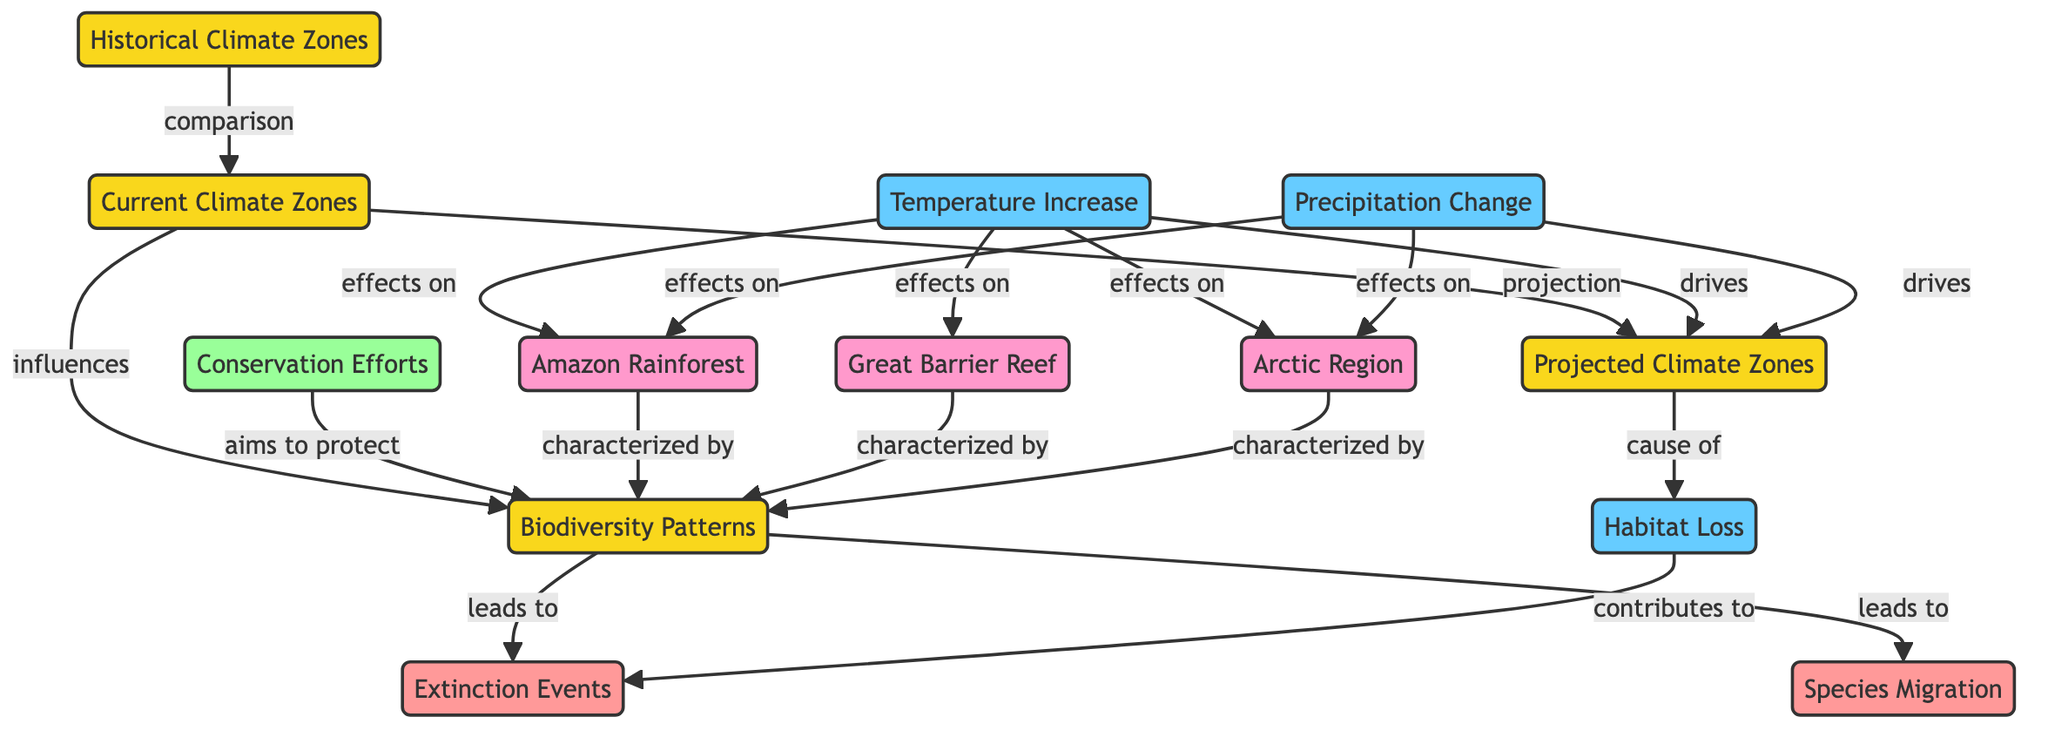What are the three types of climate zones depicted? The diagram specifies three types of climate zones: Historical Climate Zones, Current Climate Zones, and Projected Climate Zones. These are represented as distinct nodes in the diagram.
Answer: Historical Climate Zones, Current Climate Zones, Projected Climate Zones How many edges are there in the diagram? By counting the connections (or edges) between the nodes, there are a total of 14 edges that illustrate the relationships between the concepts.
Answer: 14 Which node leads to species migration? The diagram clearly shows that Biodiversity Patterns leads to Species Migration, indicating that changes in biodiversity can affect migration patterns of species.
Answer: Biodiversity Patterns What drives the projected climate zones? The edges in the diagram indicate that both Temperature Increase and Precipitation Change drive the Projected Climate Zones.
Answer: Temperature Increase and Precipitation Change What contributes to extinction events? The diagram indicates that Habitat Loss contributes to Extinction Events, suggesting that the loss of habitats can threaten species survival, leading to extinction.
Answer: Habitat Loss Which climate zone is characterized by the Amazon Rainforest? The diagram shows that Biodiversity Patterns is characterized by the Amazon Rainforest, indicating the richness of biodiversity found in that location.
Answer: Biodiversity Patterns How many impacts are shown in the diagram? By counting the nodes categorized as impacts, there are three distinct impacts shown: Temperature Increase, Precipitation Change, and Habitat Loss.
Answer: 3 What does Conservation Efforts aim to protect? The diagram delineates that Conservation Efforts aim to protect Biodiversity Patterns, emphasizing the goal of protecting diverse ecosystems and species.
Answer: Biodiversity Patterns What is the relationship between temperature increase and the Arctic Region? The edge labeled "effects on" shows that Temperature Increase has a direct effect on the Arctic Region, indicating a significant impact of rising temperatures in that location.
Answer: effects on Which location is connected to extinction events through Habitat Loss? The diagram illustrates that Habitat Loss, which is a cause of extinction events, is linked to Biodiversity Patterns, but does not directly connect a specific location to extinction events. The connection is indirect through Biodiversity Patterns.
Answer: Biodiversity Patterns 